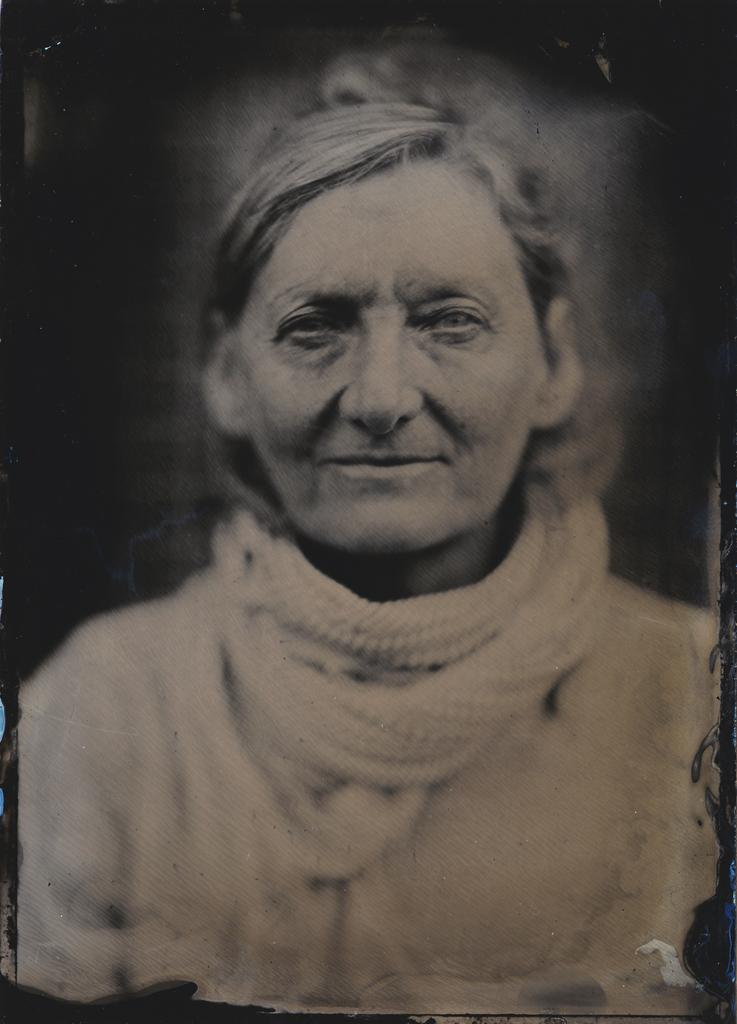What is the main subject of the image? There is a photocopy of a woman in the center of the image. What is the name of the woman's son in the image? There is no son present in the image, as it only features a photocopy of a woman. 